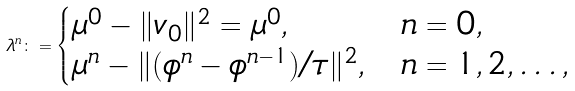Convert formula to latex. <formula><loc_0><loc_0><loc_500><loc_500>\lambda ^ { n } \colon = \begin{cases} \mu ^ { 0 } - \| v _ { 0 } \| ^ { 2 } = \mu ^ { 0 } , & n = 0 , \\ \mu ^ { n } - \| ( \phi ^ { n } - \phi ^ { n - 1 } ) / \tau \| ^ { 2 } , & n = 1 , 2 , \dots , \end{cases}</formula> 